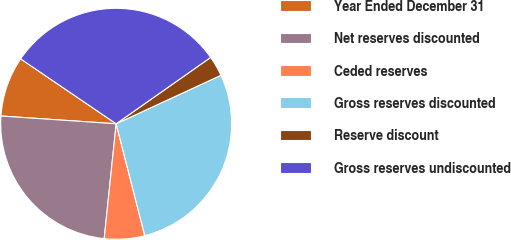Convert chart to OTSL. <chart><loc_0><loc_0><loc_500><loc_500><pie_chart><fcel>Year Ended December 31<fcel>Net reserves discounted<fcel>Ceded reserves<fcel>Gross reserves discounted<fcel>Reserve discount<fcel>Gross reserves undiscounted<nl><fcel>8.43%<fcel>24.42%<fcel>5.64%<fcel>27.91%<fcel>2.85%<fcel>30.75%<nl></chart> 